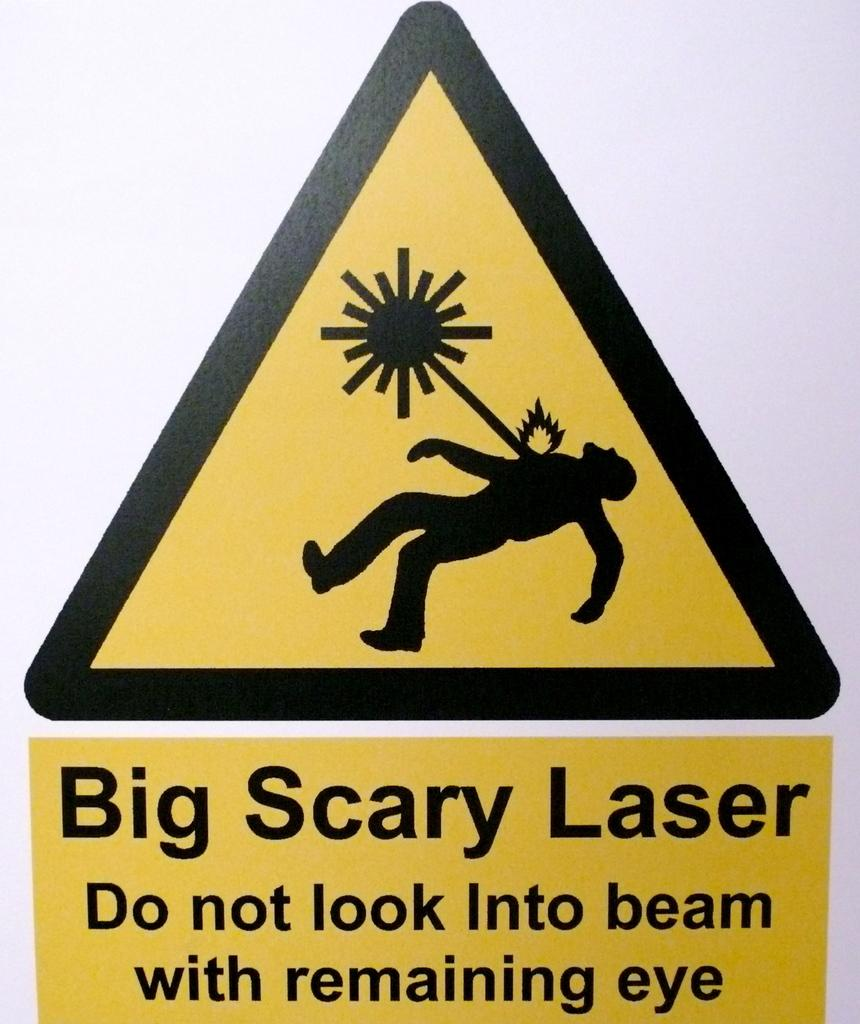<image>
Share a concise interpretation of the image provided. A caution sign warning people to not look into the beam of the laser. 